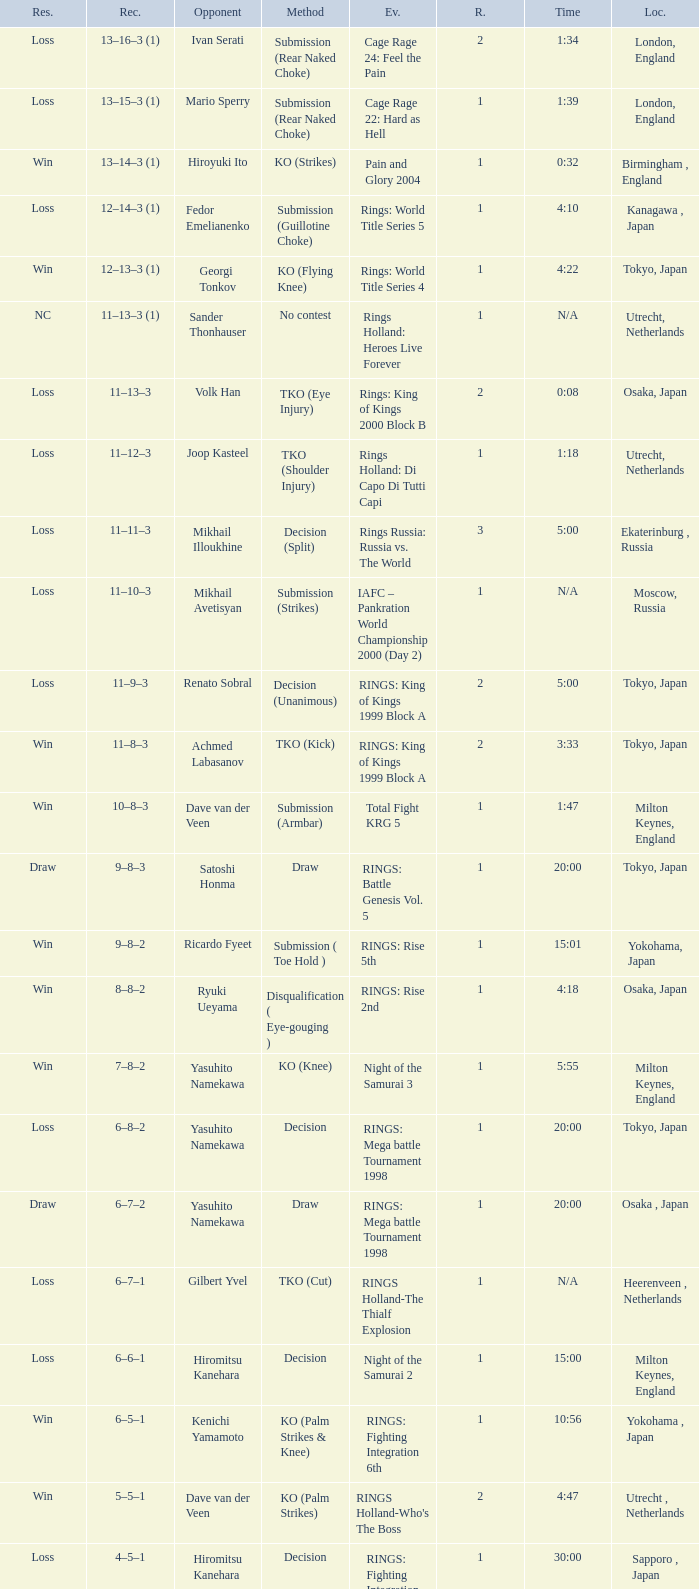When is the match time for someone opposing satoshi honma? 20:00. 